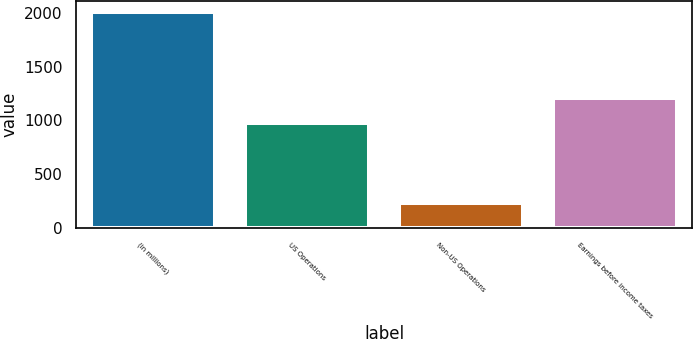<chart> <loc_0><loc_0><loc_500><loc_500><bar_chart><fcel>(in millions)<fcel>US Operations<fcel>Non-US Operations<fcel>Earnings before income taxes<nl><fcel>2010<fcel>980<fcel>232<fcel>1212<nl></chart> 